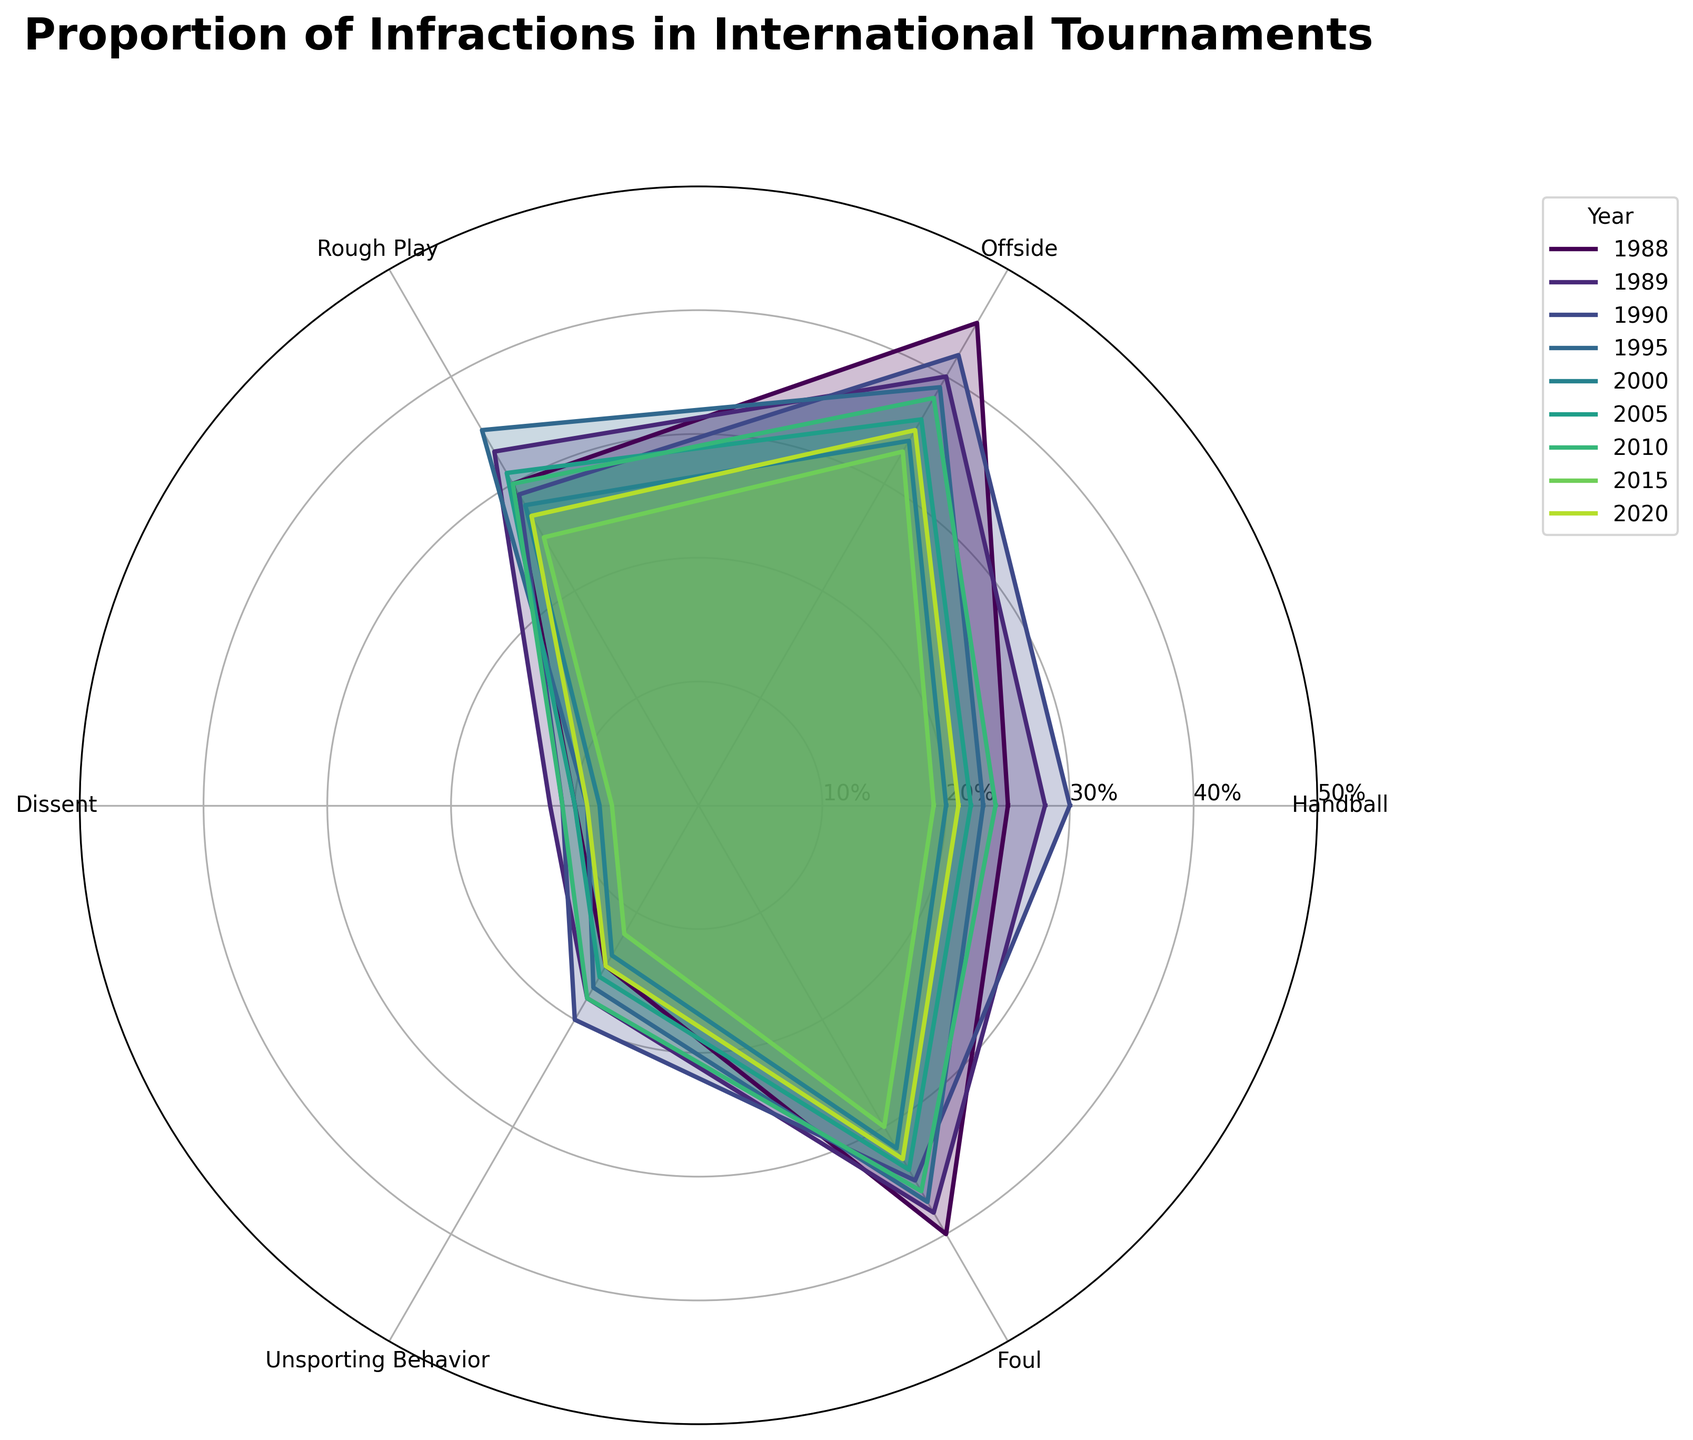What is the highest proportion of 'Offside' infractions observed over the years, according to the chart? Look for the peak of the 'Offside' dataset across all years and read the labelled value. The highest value is in 1988 at 45%.
Answer: 45% Which year had the highest proportion of ‘Handball’ infractions? Locate the point where the 'Handball' value reaches its peak and identify the corresponding year. In 1990, the 'Handball' infraction is highest at 30%.
Answer: 1990 What's the difference in the proportion of 'Rough Play' infractions between 1988 and 2015? Find the 'Rough Play' values for both 1988 and 2015, then calculate the difference: 30 (1988) - 25 (2015) = 5.
Answer: 5 Among the infractions for the year 2000, which had the lowest proportion? Identify the minimum value among the infractions for the year 2000. ‘Dissent’ has the lowest proportion at 8%.
Answer: Dissent Which year had the lowest overall proportion of infractions? Check the legend to compare the overall minimum sum of infractions for each year, focusing on the 2015 values as the lowest individual figures. Summing up each type, 2015 has the lowest combined value.
Answer: 2015 Considering infractions like ‘Unsporting Behavior’ and ‘Dissent’, in which year did the combined proportion of these two reach the highest? Sum up 'Unsporting Behavior' and 'Dissent' for each year and identify the year with the maximum total. 1989 has a combined value of 30 (18 + 12).
Answer: 1989 Do 'Foul' infractions see a noticeable trend over the years? Observe the positions of 'Foul' values across all years and identify any upward or downward trend. This category shows a fairly stable pattern around 30-40%.
Answer: Stable How does the proportion of ‘Unsporting Behavior’ infractions in 1988 compare to 2020? Compare the values for ‘Unsporting Behavior’ between 1988 and 2020 found on the respective plots. 1988 has 15% while 2020 has 15%, which indicates no change.
Answer: Equal What's the range of 'Dissent' infractions proportions observed in the entire chart? Identify the minimum and maximum values for 'Dissent' infractions and find the difference: 7% (minimum in 2015) to 12% (maximum in 1989), range is 5%.
Answer: 5 In which year did 'Foul' infractions constitute approximately 33%? Locate the year with the 'Foul' value nearest to 33% on the graph. In 2020, 'Foul' is 33%.
Answer: 2020 